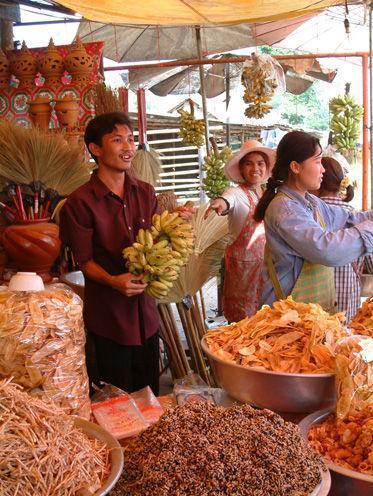How many bowls are in the picture?
Give a very brief answer. 1. How many people are visible?
Give a very brief answer. 4. How many cups on the table are wine glasses?
Give a very brief answer. 0. 